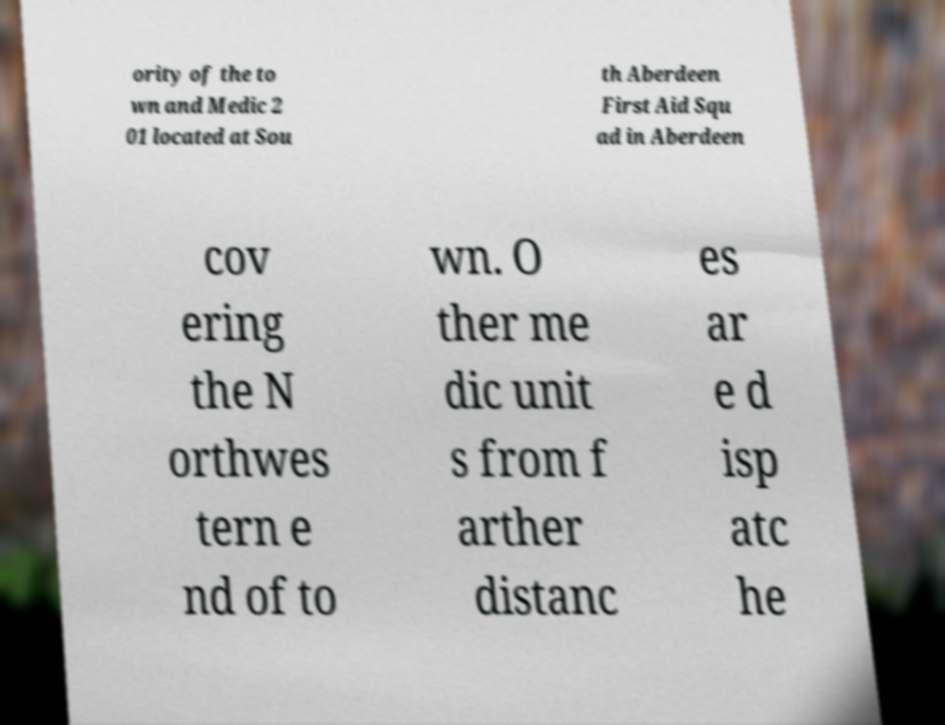What messages or text are displayed in this image? I need them in a readable, typed format. ority of the to wn and Medic 2 01 located at Sou th Aberdeen First Aid Squ ad in Aberdeen cov ering the N orthwes tern e nd of to wn. O ther me dic unit s from f arther distanc es ar e d isp atc he 